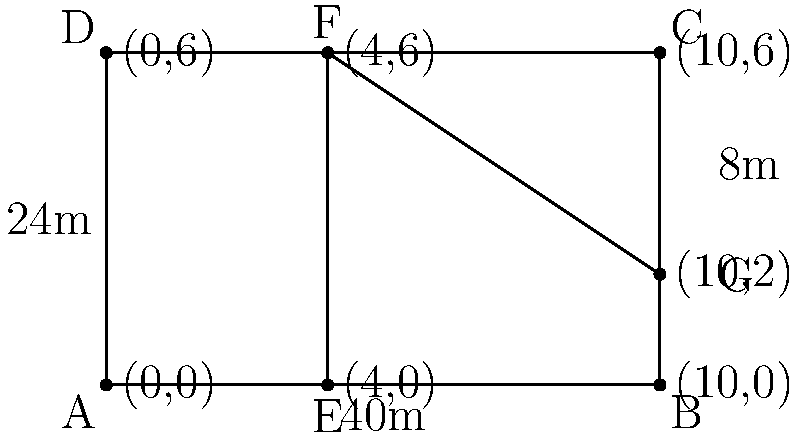As an entrepreneur looking to optimize your warehouse layout, you're presented with the floor plan above. The warehouse is a rectangle measuring 40m by 24m. A vertical partition divides the space into two sections, with the right section further divided by a diagonal partition. If the vertical partition is placed 16m from the right wall, what is the total area of the two triangular sections created by the diagonal partition? Let's approach this step-by-step:

1. First, we need to identify the dimensions of the right section of the warehouse:
   - Width: 16m
   - Height: 24m

2. The diagonal partition creates two triangles. To find their total area, we can calculate the area of the entire right section and subtract the area of the rectangle below the diagonal.

3. Area of the right section:
   $A_{right} = 16m \times 24m = 384m^2$

4. To find the area of the rectangle below the diagonal, we need its dimensions:
   - Width: 16m
   - Height: We're told this is 8m in the diagram

5. Area of the rectangle below the diagonal:
   $A_{rectangle} = 16m \times 8m = 128m^2$

6. The total area of the two triangular sections is the difference between these areas:
   $A_{triangles} = A_{right} - A_{rectangle} = 384m^2 - 128m^2 = 256m^2$

Therefore, the total area of the two triangular sections is 256 square meters.
Answer: $256m^2$ 